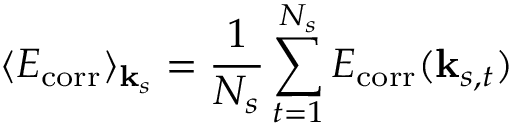<formula> <loc_0><loc_0><loc_500><loc_500>\langle E _ { c o r r } \rangle _ { { k } _ { s } } = \frac { 1 } { N _ { s } } \sum _ { t = 1 } ^ { N _ { s } } E _ { c o r r } ( { k } _ { s , t } )</formula> 